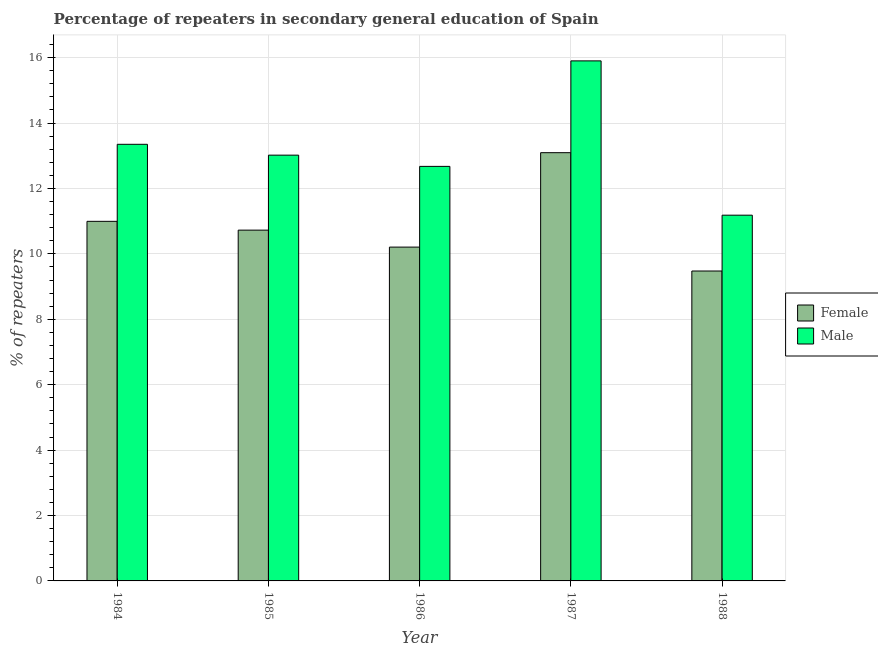How many different coloured bars are there?
Offer a very short reply. 2. How many groups of bars are there?
Ensure brevity in your answer.  5. Are the number of bars per tick equal to the number of legend labels?
Make the answer very short. Yes. How many bars are there on the 4th tick from the left?
Offer a very short reply. 2. What is the percentage of male repeaters in 1987?
Your response must be concise. 15.9. Across all years, what is the maximum percentage of female repeaters?
Give a very brief answer. 13.09. Across all years, what is the minimum percentage of male repeaters?
Give a very brief answer. 11.18. In which year was the percentage of male repeaters minimum?
Your answer should be very brief. 1988. What is the total percentage of female repeaters in the graph?
Ensure brevity in your answer.  54.49. What is the difference between the percentage of female repeaters in 1985 and that in 1987?
Make the answer very short. -2.37. What is the difference between the percentage of male repeaters in 1985 and the percentage of female repeaters in 1987?
Your answer should be compact. -2.88. What is the average percentage of female repeaters per year?
Your answer should be compact. 10.9. In the year 1987, what is the difference between the percentage of male repeaters and percentage of female repeaters?
Offer a very short reply. 0. In how many years, is the percentage of female repeaters greater than 3.2 %?
Offer a terse response. 5. What is the ratio of the percentage of female repeaters in 1984 to that in 1988?
Your response must be concise. 1.16. Is the percentage of female repeaters in 1984 less than that in 1988?
Your answer should be compact. No. What is the difference between the highest and the second highest percentage of male repeaters?
Your response must be concise. 2.55. What is the difference between the highest and the lowest percentage of male repeaters?
Offer a very short reply. 4.72. In how many years, is the percentage of male repeaters greater than the average percentage of male repeaters taken over all years?
Give a very brief answer. 2. Is the sum of the percentage of female repeaters in 1984 and 1987 greater than the maximum percentage of male repeaters across all years?
Provide a succinct answer. Yes. What does the 1st bar from the left in 1985 represents?
Ensure brevity in your answer.  Female. How many bars are there?
Provide a succinct answer. 10. Are all the bars in the graph horizontal?
Your answer should be very brief. No. What is the difference between two consecutive major ticks on the Y-axis?
Give a very brief answer. 2. Are the values on the major ticks of Y-axis written in scientific E-notation?
Your answer should be compact. No. Does the graph contain any zero values?
Your answer should be compact. No. Where does the legend appear in the graph?
Your answer should be very brief. Center right. How are the legend labels stacked?
Provide a short and direct response. Vertical. What is the title of the graph?
Ensure brevity in your answer.  Percentage of repeaters in secondary general education of Spain. What is the label or title of the X-axis?
Make the answer very short. Year. What is the label or title of the Y-axis?
Offer a terse response. % of repeaters. What is the % of repeaters of Female in 1984?
Provide a succinct answer. 10.99. What is the % of repeaters in Male in 1984?
Your response must be concise. 13.35. What is the % of repeaters in Female in 1985?
Offer a terse response. 10.73. What is the % of repeaters in Male in 1985?
Your answer should be compact. 13.02. What is the % of repeaters of Female in 1986?
Provide a short and direct response. 10.21. What is the % of repeaters of Male in 1986?
Ensure brevity in your answer.  12.67. What is the % of repeaters of Female in 1987?
Provide a succinct answer. 13.09. What is the % of repeaters in Male in 1987?
Offer a terse response. 15.9. What is the % of repeaters in Female in 1988?
Your answer should be compact. 9.48. What is the % of repeaters of Male in 1988?
Offer a very short reply. 11.18. Across all years, what is the maximum % of repeaters in Female?
Your response must be concise. 13.09. Across all years, what is the maximum % of repeaters of Male?
Offer a very short reply. 15.9. Across all years, what is the minimum % of repeaters in Female?
Give a very brief answer. 9.48. Across all years, what is the minimum % of repeaters in Male?
Offer a very short reply. 11.18. What is the total % of repeaters in Female in the graph?
Ensure brevity in your answer.  54.49. What is the total % of repeaters of Male in the graph?
Keep it short and to the point. 66.12. What is the difference between the % of repeaters in Female in 1984 and that in 1985?
Make the answer very short. 0.27. What is the difference between the % of repeaters of Male in 1984 and that in 1985?
Your response must be concise. 0.33. What is the difference between the % of repeaters in Female in 1984 and that in 1986?
Provide a succinct answer. 0.79. What is the difference between the % of repeaters in Male in 1984 and that in 1986?
Ensure brevity in your answer.  0.68. What is the difference between the % of repeaters in Female in 1984 and that in 1987?
Provide a succinct answer. -2.1. What is the difference between the % of repeaters of Male in 1984 and that in 1987?
Give a very brief answer. -2.55. What is the difference between the % of repeaters of Female in 1984 and that in 1988?
Your answer should be very brief. 1.52. What is the difference between the % of repeaters of Male in 1984 and that in 1988?
Offer a very short reply. 2.17. What is the difference between the % of repeaters of Female in 1985 and that in 1986?
Provide a succinct answer. 0.52. What is the difference between the % of repeaters in Male in 1985 and that in 1986?
Keep it short and to the point. 0.34. What is the difference between the % of repeaters in Female in 1985 and that in 1987?
Offer a very short reply. -2.37. What is the difference between the % of repeaters of Male in 1985 and that in 1987?
Your response must be concise. -2.88. What is the difference between the % of repeaters in Female in 1985 and that in 1988?
Offer a very short reply. 1.25. What is the difference between the % of repeaters in Male in 1985 and that in 1988?
Keep it short and to the point. 1.84. What is the difference between the % of repeaters in Female in 1986 and that in 1987?
Keep it short and to the point. -2.89. What is the difference between the % of repeaters of Male in 1986 and that in 1987?
Offer a very short reply. -3.23. What is the difference between the % of repeaters of Female in 1986 and that in 1988?
Keep it short and to the point. 0.73. What is the difference between the % of repeaters of Male in 1986 and that in 1988?
Give a very brief answer. 1.49. What is the difference between the % of repeaters of Female in 1987 and that in 1988?
Keep it short and to the point. 3.62. What is the difference between the % of repeaters of Male in 1987 and that in 1988?
Provide a succinct answer. 4.72. What is the difference between the % of repeaters of Female in 1984 and the % of repeaters of Male in 1985?
Offer a terse response. -2.02. What is the difference between the % of repeaters in Female in 1984 and the % of repeaters in Male in 1986?
Provide a short and direct response. -1.68. What is the difference between the % of repeaters in Female in 1984 and the % of repeaters in Male in 1987?
Your answer should be compact. -4.91. What is the difference between the % of repeaters in Female in 1984 and the % of repeaters in Male in 1988?
Give a very brief answer. -0.19. What is the difference between the % of repeaters of Female in 1985 and the % of repeaters of Male in 1986?
Keep it short and to the point. -1.95. What is the difference between the % of repeaters of Female in 1985 and the % of repeaters of Male in 1987?
Your answer should be very brief. -5.17. What is the difference between the % of repeaters of Female in 1985 and the % of repeaters of Male in 1988?
Your answer should be very brief. -0.46. What is the difference between the % of repeaters of Female in 1986 and the % of repeaters of Male in 1987?
Offer a terse response. -5.69. What is the difference between the % of repeaters of Female in 1986 and the % of repeaters of Male in 1988?
Offer a terse response. -0.98. What is the difference between the % of repeaters in Female in 1987 and the % of repeaters in Male in 1988?
Give a very brief answer. 1.91. What is the average % of repeaters of Female per year?
Give a very brief answer. 10.9. What is the average % of repeaters of Male per year?
Give a very brief answer. 13.22. In the year 1984, what is the difference between the % of repeaters of Female and % of repeaters of Male?
Provide a short and direct response. -2.36. In the year 1985, what is the difference between the % of repeaters in Female and % of repeaters in Male?
Provide a short and direct response. -2.29. In the year 1986, what is the difference between the % of repeaters in Female and % of repeaters in Male?
Provide a short and direct response. -2.47. In the year 1987, what is the difference between the % of repeaters of Female and % of repeaters of Male?
Your answer should be very brief. -2.81. In the year 1988, what is the difference between the % of repeaters in Female and % of repeaters in Male?
Keep it short and to the point. -1.71. What is the ratio of the % of repeaters of Female in 1984 to that in 1985?
Offer a terse response. 1.03. What is the ratio of the % of repeaters in Male in 1984 to that in 1985?
Your response must be concise. 1.03. What is the ratio of the % of repeaters in Female in 1984 to that in 1986?
Offer a very short reply. 1.08. What is the ratio of the % of repeaters of Male in 1984 to that in 1986?
Your answer should be very brief. 1.05. What is the ratio of the % of repeaters in Female in 1984 to that in 1987?
Your answer should be compact. 0.84. What is the ratio of the % of repeaters in Male in 1984 to that in 1987?
Offer a terse response. 0.84. What is the ratio of the % of repeaters of Female in 1984 to that in 1988?
Your answer should be very brief. 1.16. What is the ratio of the % of repeaters in Male in 1984 to that in 1988?
Offer a very short reply. 1.19. What is the ratio of the % of repeaters in Female in 1985 to that in 1986?
Ensure brevity in your answer.  1.05. What is the ratio of the % of repeaters of Male in 1985 to that in 1986?
Give a very brief answer. 1.03. What is the ratio of the % of repeaters of Female in 1985 to that in 1987?
Offer a very short reply. 0.82. What is the ratio of the % of repeaters in Male in 1985 to that in 1987?
Make the answer very short. 0.82. What is the ratio of the % of repeaters in Female in 1985 to that in 1988?
Provide a succinct answer. 1.13. What is the ratio of the % of repeaters of Male in 1985 to that in 1988?
Make the answer very short. 1.16. What is the ratio of the % of repeaters of Female in 1986 to that in 1987?
Make the answer very short. 0.78. What is the ratio of the % of repeaters in Male in 1986 to that in 1987?
Make the answer very short. 0.8. What is the ratio of the % of repeaters of Female in 1986 to that in 1988?
Your answer should be compact. 1.08. What is the ratio of the % of repeaters in Male in 1986 to that in 1988?
Give a very brief answer. 1.13. What is the ratio of the % of repeaters of Female in 1987 to that in 1988?
Your answer should be very brief. 1.38. What is the ratio of the % of repeaters of Male in 1987 to that in 1988?
Your answer should be very brief. 1.42. What is the difference between the highest and the second highest % of repeaters in Female?
Your answer should be compact. 2.1. What is the difference between the highest and the second highest % of repeaters of Male?
Your response must be concise. 2.55. What is the difference between the highest and the lowest % of repeaters of Female?
Offer a very short reply. 3.62. What is the difference between the highest and the lowest % of repeaters in Male?
Your response must be concise. 4.72. 